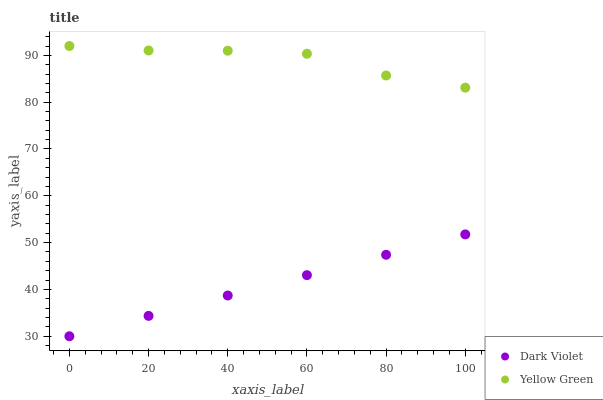Does Dark Violet have the minimum area under the curve?
Answer yes or no. Yes. Does Yellow Green have the maximum area under the curve?
Answer yes or no. Yes. Does Dark Violet have the maximum area under the curve?
Answer yes or no. No. Is Dark Violet the smoothest?
Answer yes or no. Yes. Is Yellow Green the roughest?
Answer yes or no. Yes. Is Dark Violet the roughest?
Answer yes or no. No. Does Dark Violet have the lowest value?
Answer yes or no. Yes. Does Yellow Green have the highest value?
Answer yes or no. Yes. Does Dark Violet have the highest value?
Answer yes or no. No. Is Dark Violet less than Yellow Green?
Answer yes or no. Yes. Is Yellow Green greater than Dark Violet?
Answer yes or no. Yes. Does Dark Violet intersect Yellow Green?
Answer yes or no. No. 